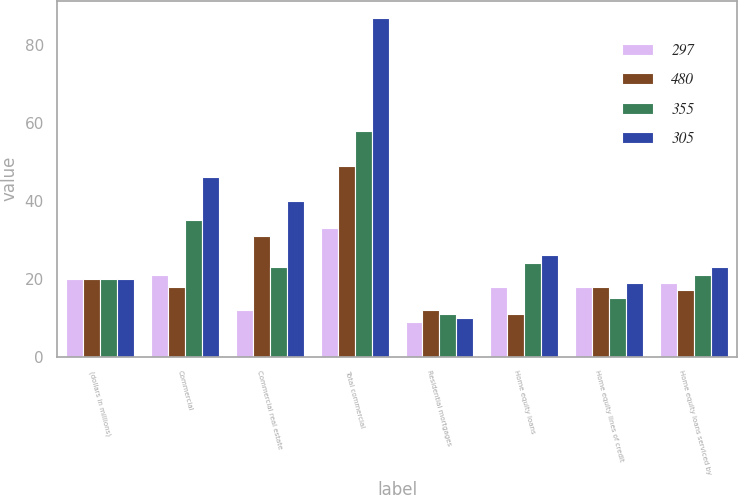<chart> <loc_0><loc_0><loc_500><loc_500><stacked_bar_chart><ecel><fcel>(dollars in millions)<fcel>Commercial<fcel>Commercial real estate<fcel>Total commercial<fcel>Residential mortgages<fcel>Home equity loans<fcel>Home equity lines of credit<fcel>Home equity loans serviced by<nl><fcel>297<fcel>20<fcel>21<fcel>12<fcel>33<fcel>9<fcel>18<fcel>18<fcel>19<nl><fcel>480<fcel>20<fcel>18<fcel>31<fcel>49<fcel>12<fcel>11<fcel>18<fcel>17<nl><fcel>355<fcel>20<fcel>35<fcel>23<fcel>58<fcel>11<fcel>24<fcel>15<fcel>21<nl><fcel>305<fcel>20<fcel>46<fcel>40<fcel>87<fcel>10<fcel>26<fcel>19<fcel>23<nl></chart> 